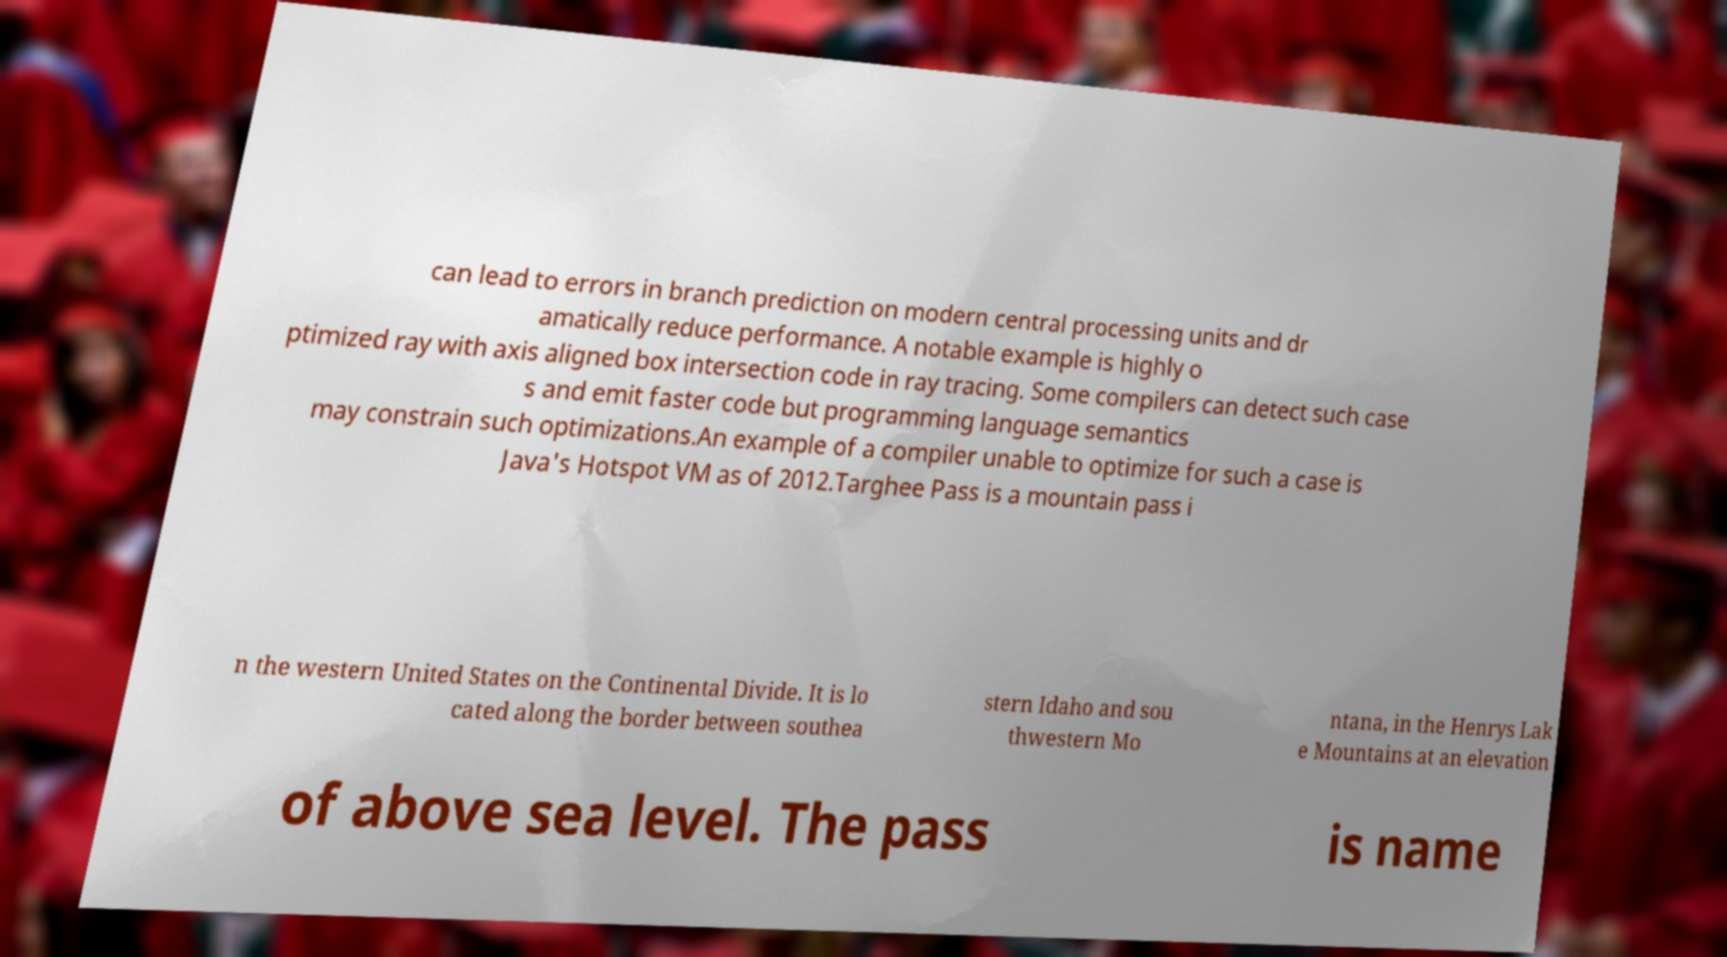Can you read and provide the text displayed in the image?This photo seems to have some interesting text. Can you extract and type it out for me? can lead to errors in branch prediction on modern central processing units and dr amatically reduce performance. A notable example is highly o ptimized ray with axis aligned box intersection code in ray tracing. Some compilers can detect such case s and emit faster code but programming language semantics may constrain such optimizations.An example of a compiler unable to optimize for such a case is Java's Hotspot VM as of 2012.Targhee Pass is a mountain pass i n the western United States on the Continental Divide. It is lo cated along the border between southea stern Idaho and sou thwestern Mo ntana, in the Henrys Lak e Mountains at an elevation of above sea level. The pass is name 